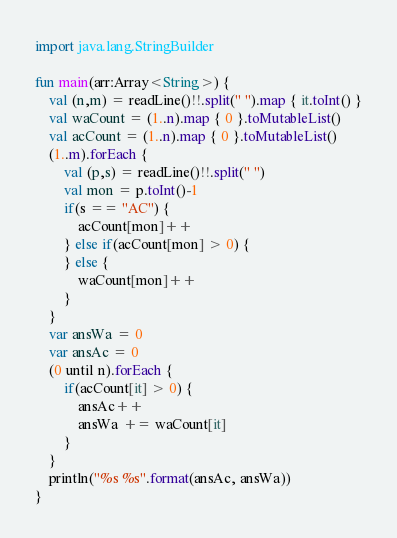Convert code to text. <code><loc_0><loc_0><loc_500><loc_500><_Kotlin_>import java.lang.StringBuilder

fun main(arr:Array<String>) {
    val (n,m) = readLine()!!.split(" ").map { it.toInt() }
    val waCount = (1..n).map { 0 }.toMutableList()
    val acCount = (1..n).map { 0 }.toMutableList()
    (1..m).forEach {
        val (p,s) = readLine()!!.split(" ")
        val mon = p.toInt()-1
        if(s == "AC") {
            acCount[mon]++
        } else if(acCount[mon] > 0) {
        } else {
            waCount[mon]++
        }
    }
    var ansWa = 0
    var ansAc = 0
    (0 until n).forEach {
        if(acCount[it] > 0) {
            ansAc++
            ansWa += waCount[it]
        }
    }
    println("%s %s".format(ansAc, ansWa))
}
</code> 